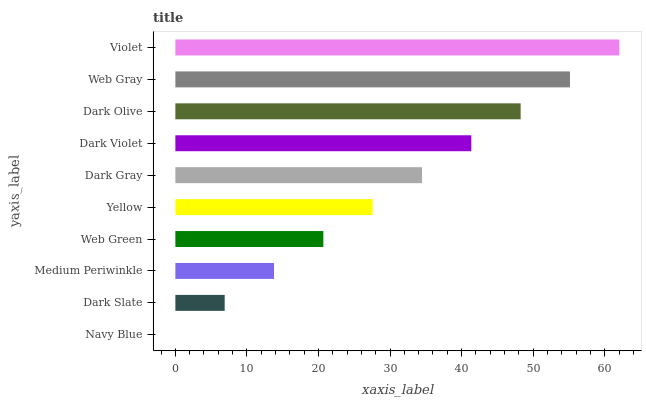Is Navy Blue the minimum?
Answer yes or no. Yes. Is Violet the maximum?
Answer yes or no. Yes. Is Dark Slate the minimum?
Answer yes or no. No. Is Dark Slate the maximum?
Answer yes or no. No. Is Dark Slate greater than Navy Blue?
Answer yes or no. Yes. Is Navy Blue less than Dark Slate?
Answer yes or no. Yes. Is Navy Blue greater than Dark Slate?
Answer yes or no. No. Is Dark Slate less than Navy Blue?
Answer yes or no. No. Is Dark Gray the high median?
Answer yes or no. Yes. Is Yellow the low median?
Answer yes or no. Yes. Is Web Gray the high median?
Answer yes or no. No. Is Web Gray the low median?
Answer yes or no. No. 